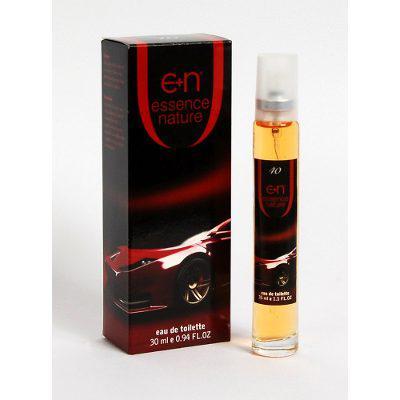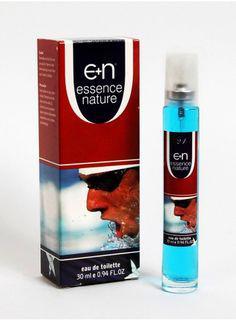The first image is the image on the left, the second image is the image on the right. Evaluate the accuracy of this statement regarding the images: "Each image shows one upright fragrance bottle to the right of its box, and one of the images features a box with a sports car on its front.". Is it true? Answer yes or no. Yes. The first image is the image on the left, the second image is the image on the right. Considering the images on both sides, is "The right image contains a slim container with blue liquid inside it." valid? Answer yes or no. Yes. 